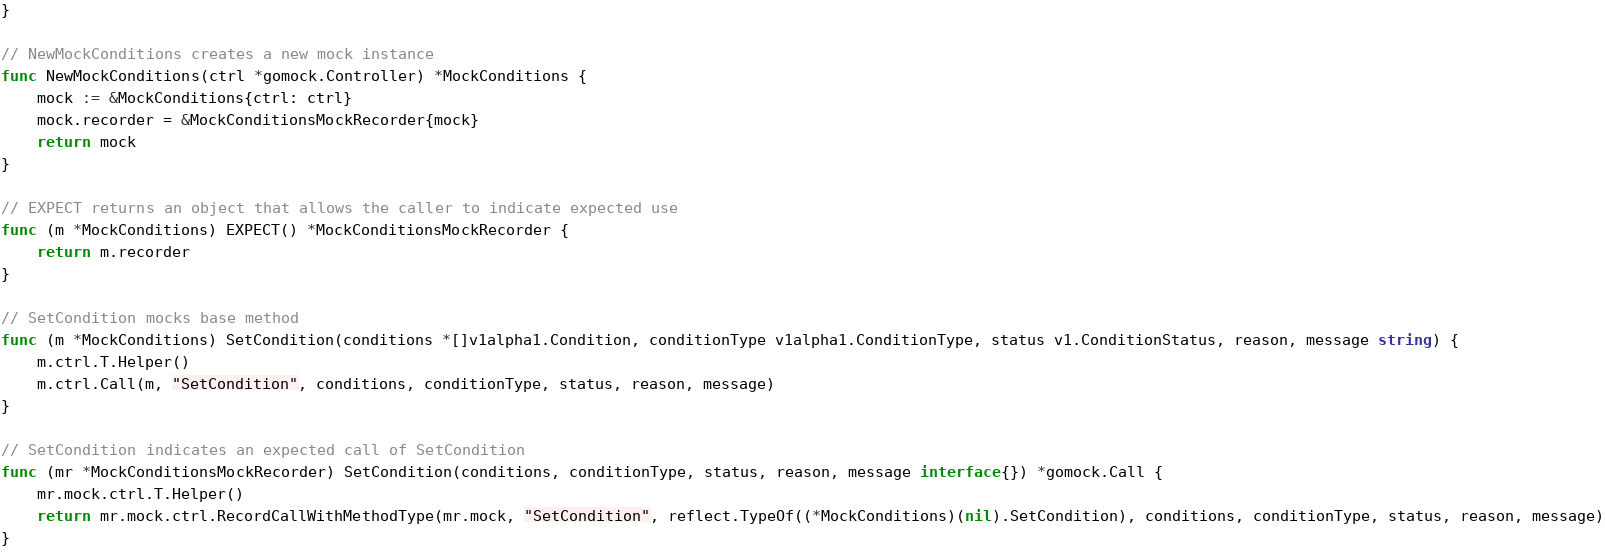Convert code to text. <code><loc_0><loc_0><loc_500><loc_500><_Go_>}

// NewMockConditions creates a new mock instance
func NewMockConditions(ctrl *gomock.Controller) *MockConditions {
	mock := &MockConditions{ctrl: ctrl}
	mock.recorder = &MockConditionsMockRecorder{mock}
	return mock
}

// EXPECT returns an object that allows the caller to indicate expected use
func (m *MockConditions) EXPECT() *MockConditionsMockRecorder {
	return m.recorder
}

// SetCondition mocks base method
func (m *MockConditions) SetCondition(conditions *[]v1alpha1.Condition, conditionType v1alpha1.ConditionType, status v1.ConditionStatus, reason, message string) {
	m.ctrl.T.Helper()
	m.ctrl.Call(m, "SetCondition", conditions, conditionType, status, reason, message)
}

// SetCondition indicates an expected call of SetCondition
func (mr *MockConditionsMockRecorder) SetCondition(conditions, conditionType, status, reason, message interface{}) *gomock.Call {
	mr.mock.ctrl.T.Helper()
	return mr.mock.ctrl.RecordCallWithMethodType(mr.mock, "SetCondition", reflect.TypeOf((*MockConditions)(nil).SetCondition), conditions, conditionType, status, reason, message)
}
</code> 